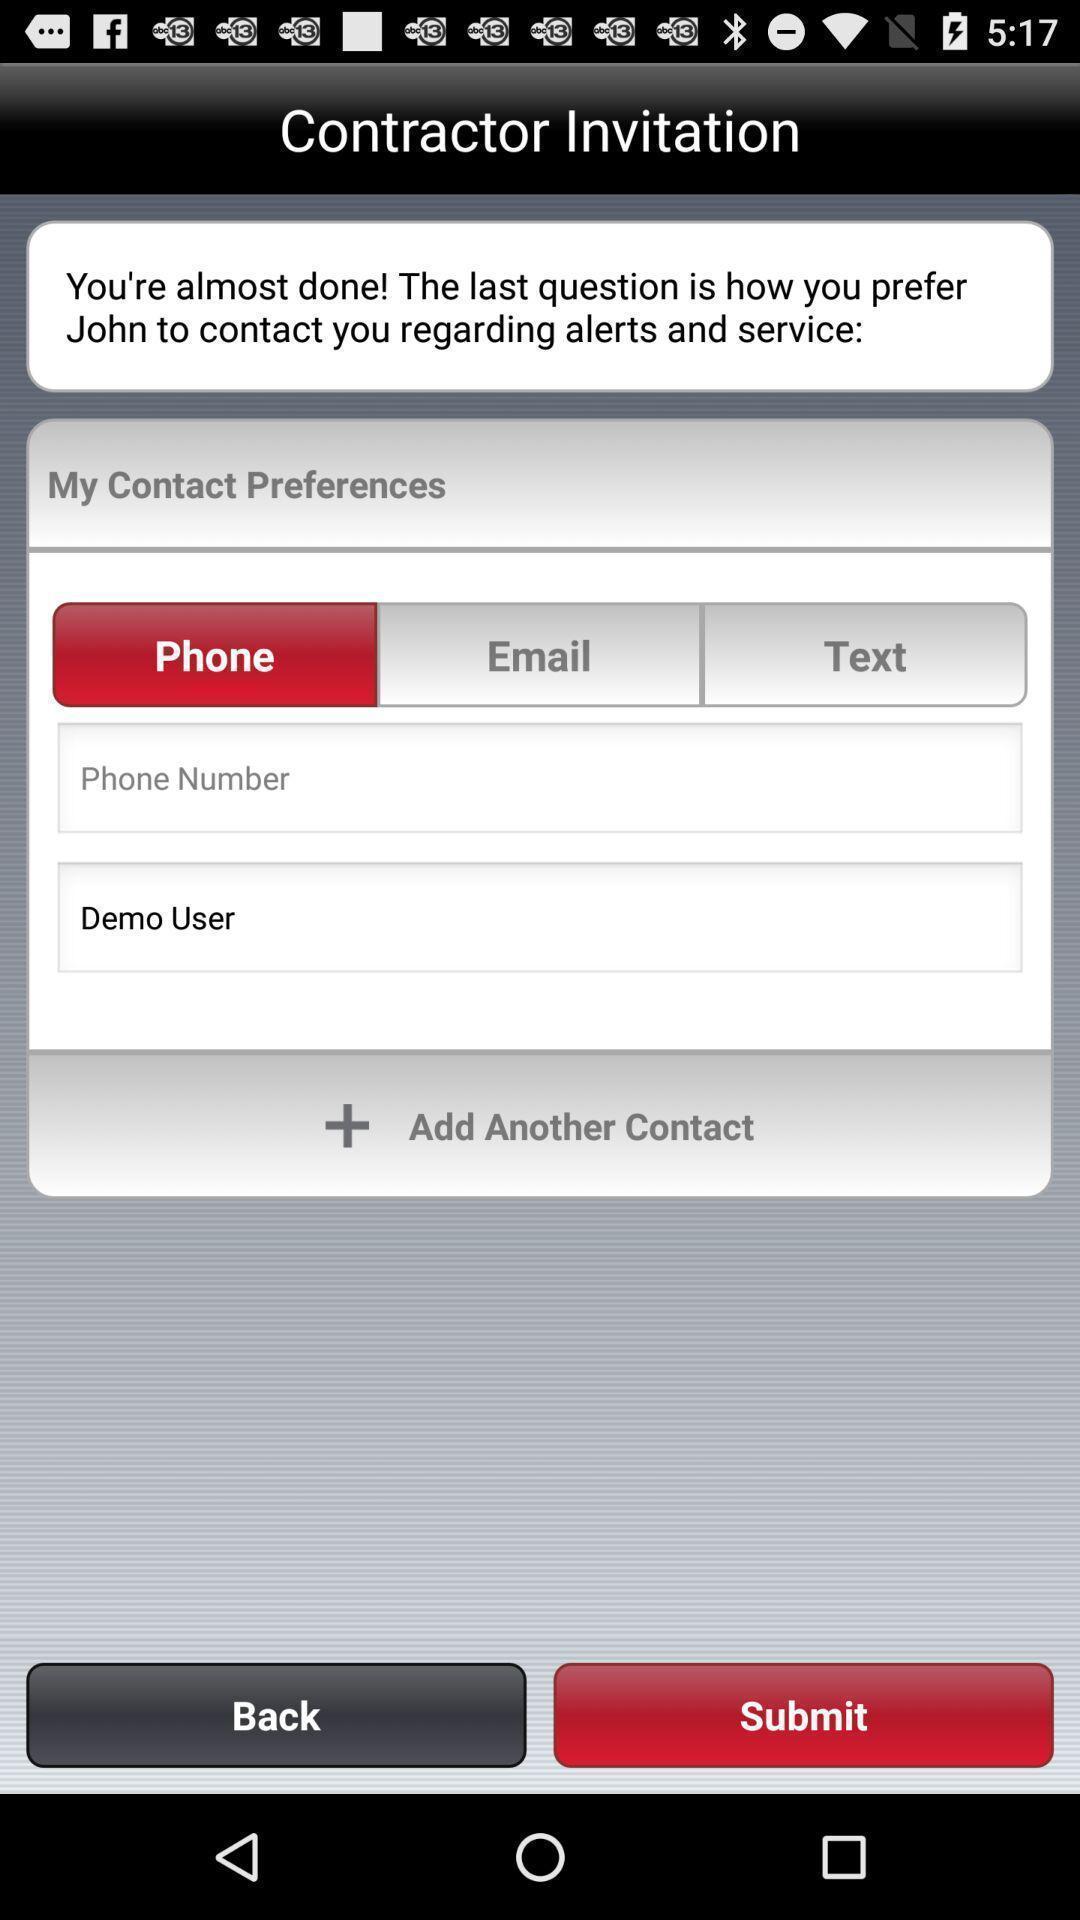Summarize the main components in this picture. Page displaying to add a contact. 